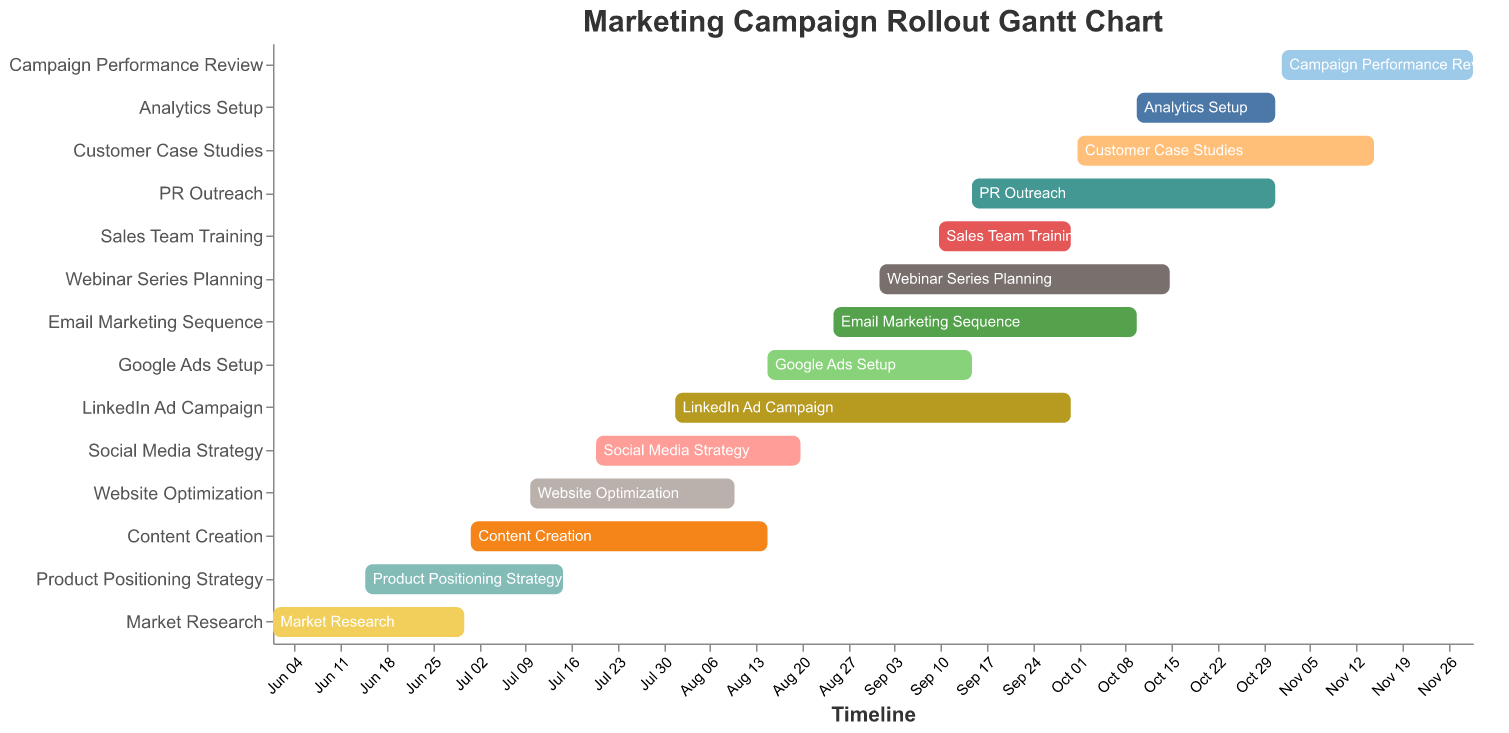What is the duration of the "Market Research" task? The figure lists the "Market Research" task, which starts on 2023-06-01 and ends on 2023-06-30. The duration is calculated as the number of days from the start to the end date, including both days.
Answer: 30 days When does the "Social Media Strategy" task begin and end? By referring to the figure, the "Social Media Strategy" task starts on 2023-07-20 and ends on 2023-08-20, as indicated by the timeline provided.
Answer: Starts: 2023-07-20, Ends: 2023-08-20 Which task has the longest duration, and how many days is it? The figure shows different tasks with varying durations. The task "LinkedIn Ad Campaign" has the longest duration of 61 days, starting on 2023-08-01 and ending on 2023-09-30.
Answer: "LinkedIn Ad Campaign", 61 days How many tasks are happening concurrently during August 2023? By visually inspecting the Gantt chart, we can count the overlapping bars during the period of August 2023. These tasks include "Content Creation", "Website Optimization", "Social Media Strategy", "LinkedIn Ad Campaign", "Google Ads Setup", and "Email Marketing Sequence".
Answer: 6 tasks What is the gap length between the end of "Content Creation" and the start of "LinkedIn Ad Campaign"? The "Content Creation" ends on 2023-08-15 and the "LinkedIn Ad Campaign" starts on 2023-08-01. However, since the "LinkedIn Ad Campaign" starts before "Content Creation" ends, there is no gap between them.
Answer: 0 days Which tasks overlap with "Sales Team Training"? The "Sales Team Training" starts on 2023-09-10 and ends on 2023-09-30. The overlapping tasks within this period are "LinkedIn Ad Campaign", "Google Ads Setup", "Webinar Series Planning", and "PR Outreach".
Answer: "LinkedIn Ad Campaign", "Google Ads Setup", "Webinar Series Planning", "PR Outreach" When does "Campaign Performance Review" start and which tasks are still ongoing when it begins? "Campaign Performance Review" starts on 2023-11-01. The only task that is still ongoing at this date is "Customer Case Studies", ending 2023-11-15.
Answer: Starts: 2023-11-01, Ongoing Task: "Customer Case Studies" Which tasks start in July 2023, and how many are there? Referring to the figure, tasks starting in July 2023 are "Content Creation" on 2023-07-01, "Website Optimization" on 2023-07-10, and "Social Media Strategy" on 2023-07-20. Therefore, there are three tasks.
Answer: 3 tasks ("Content Creation", "Website Optimization", "Social Media Strategy") 